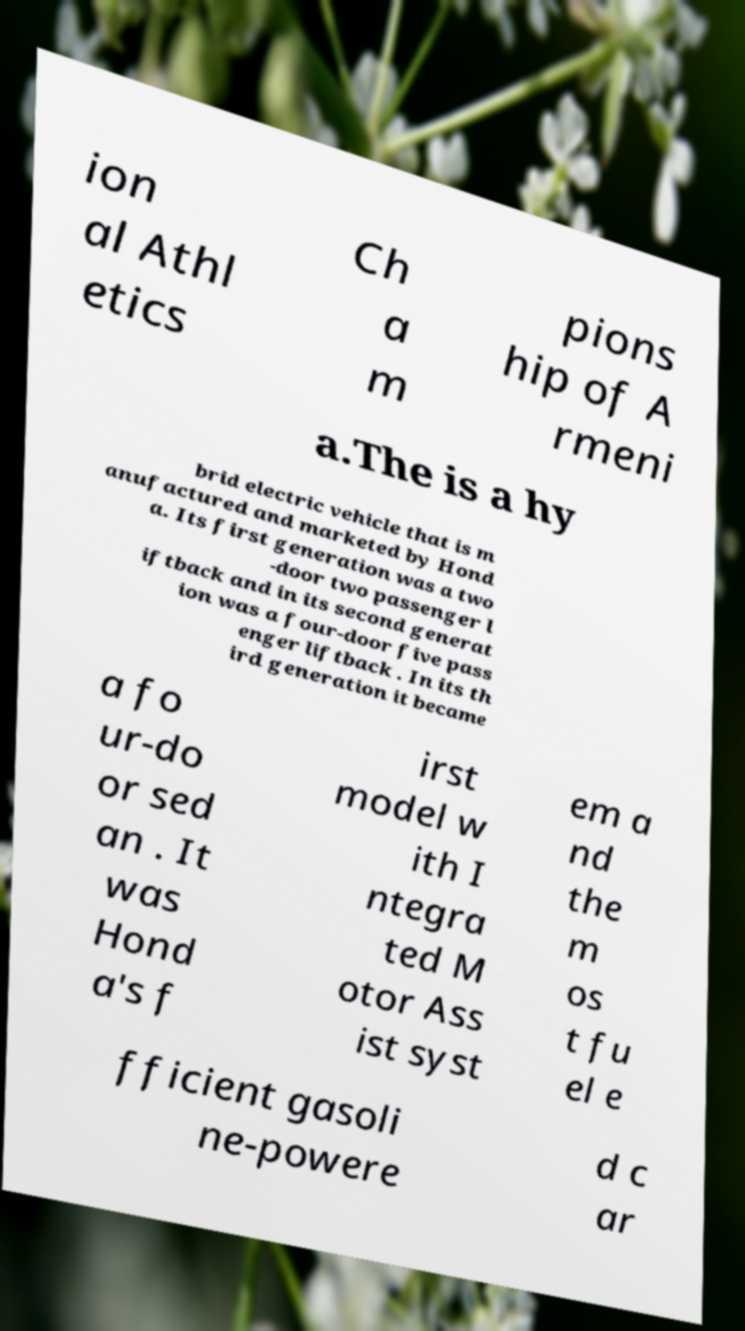Can you read and provide the text displayed in the image?This photo seems to have some interesting text. Can you extract and type it out for me? ion al Athl etics Ch a m pions hip of A rmeni a.The is a hy brid electric vehicle that is m anufactured and marketed by Hond a. Its first generation was a two -door two passenger l iftback and in its second generat ion was a four-door five pass enger liftback . In its th ird generation it became a fo ur-do or sed an . It was Hond a's f irst model w ith I ntegra ted M otor Ass ist syst em a nd the m os t fu el e fficient gasoli ne-powere d c ar 